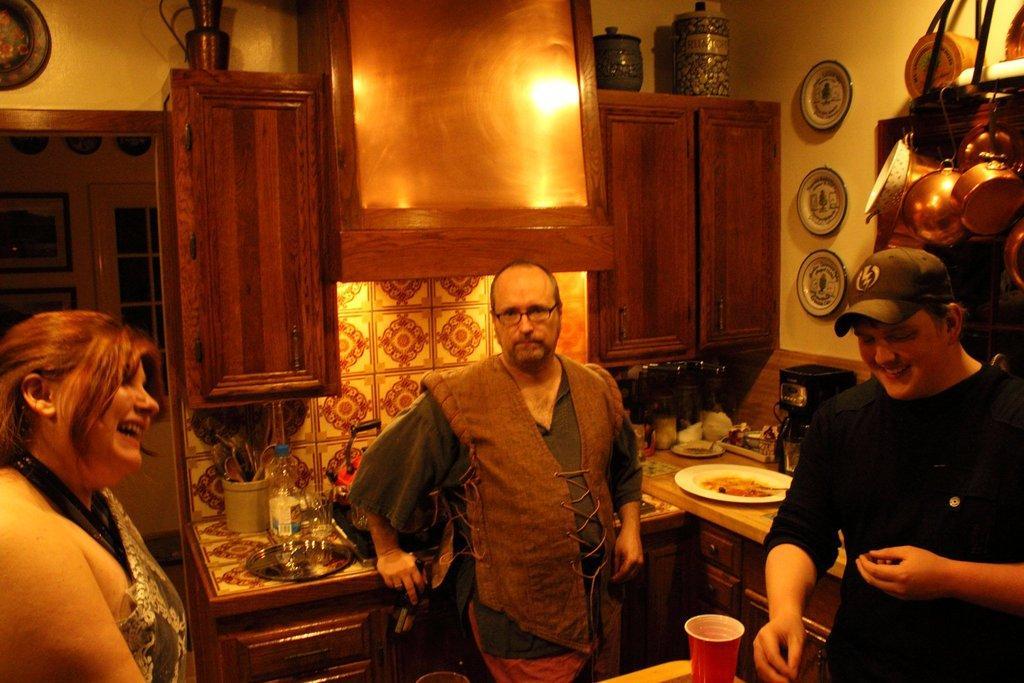Could you give a brief overview of what you see in this image? In this image there are people and we can see a countertop. There are things placed on the countertop. On the right there are vessels. In the background we can see a chimney and there are vases placed on the cupboard. On the left there is a door and we can see frames placed on the wall. There is a window. 